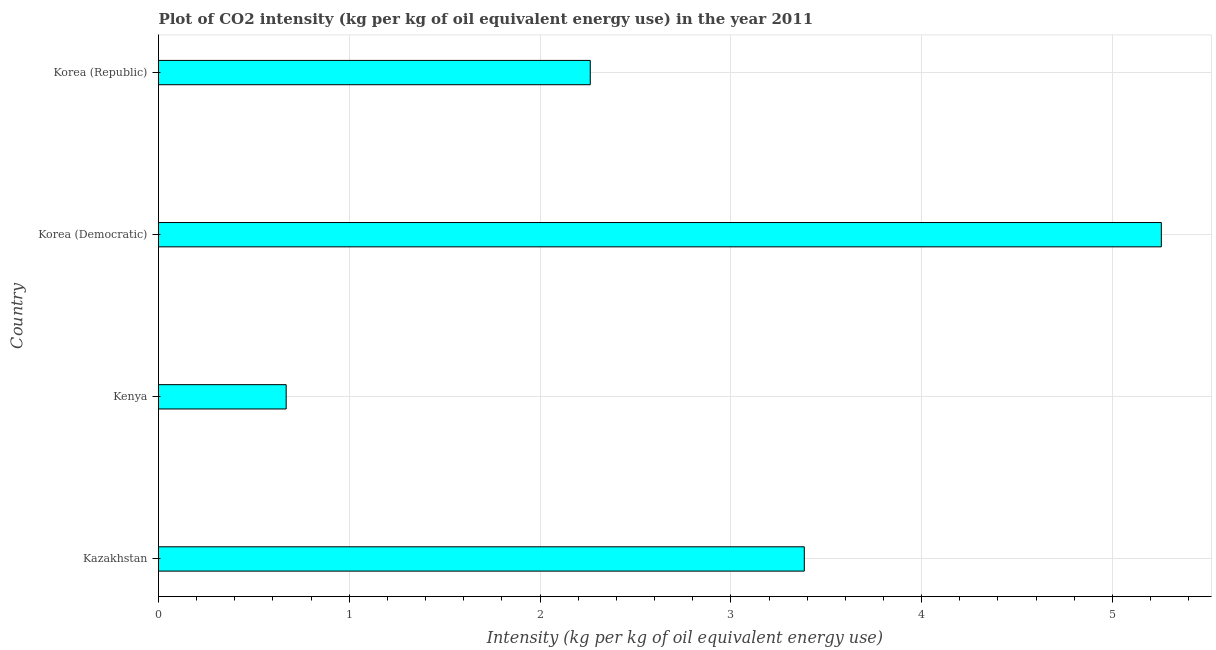What is the title of the graph?
Give a very brief answer. Plot of CO2 intensity (kg per kg of oil equivalent energy use) in the year 2011. What is the label or title of the X-axis?
Your response must be concise. Intensity (kg per kg of oil equivalent energy use). What is the label or title of the Y-axis?
Your answer should be very brief. Country. What is the co2 intensity in Korea (Democratic)?
Your answer should be very brief. 5.26. Across all countries, what is the maximum co2 intensity?
Make the answer very short. 5.26. Across all countries, what is the minimum co2 intensity?
Ensure brevity in your answer.  0.67. In which country was the co2 intensity maximum?
Your answer should be very brief. Korea (Democratic). In which country was the co2 intensity minimum?
Your answer should be very brief. Kenya. What is the sum of the co2 intensity?
Your answer should be compact. 11.57. What is the difference between the co2 intensity in Kenya and Korea (Republic)?
Offer a very short reply. -1.59. What is the average co2 intensity per country?
Ensure brevity in your answer.  2.89. What is the median co2 intensity?
Offer a very short reply. 2.82. What is the ratio of the co2 intensity in Kazakhstan to that in Korea (Democratic)?
Provide a short and direct response. 0.64. Is the co2 intensity in Kenya less than that in Korea (Democratic)?
Give a very brief answer. Yes. What is the difference between the highest and the second highest co2 intensity?
Provide a succinct answer. 1.87. What is the difference between the highest and the lowest co2 intensity?
Your response must be concise. 4.59. In how many countries, is the co2 intensity greater than the average co2 intensity taken over all countries?
Your answer should be very brief. 2. What is the difference between two consecutive major ticks on the X-axis?
Offer a very short reply. 1. Are the values on the major ticks of X-axis written in scientific E-notation?
Ensure brevity in your answer.  No. What is the Intensity (kg per kg of oil equivalent energy use) of Kazakhstan?
Keep it short and to the point. 3.38. What is the Intensity (kg per kg of oil equivalent energy use) in Kenya?
Your answer should be very brief. 0.67. What is the Intensity (kg per kg of oil equivalent energy use) of Korea (Democratic)?
Provide a short and direct response. 5.26. What is the Intensity (kg per kg of oil equivalent energy use) of Korea (Republic)?
Provide a succinct answer. 2.26. What is the difference between the Intensity (kg per kg of oil equivalent energy use) in Kazakhstan and Kenya?
Offer a very short reply. 2.72. What is the difference between the Intensity (kg per kg of oil equivalent energy use) in Kazakhstan and Korea (Democratic)?
Your response must be concise. -1.87. What is the difference between the Intensity (kg per kg of oil equivalent energy use) in Kazakhstan and Korea (Republic)?
Offer a terse response. 1.12. What is the difference between the Intensity (kg per kg of oil equivalent energy use) in Kenya and Korea (Democratic)?
Your answer should be compact. -4.59. What is the difference between the Intensity (kg per kg of oil equivalent energy use) in Kenya and Korea (Republic)?
Provide a succinct answer. -1.59. What is the difference between the Intensity (kg per kg of oil equivalent energy use) in Korea (Democratic) and Korea (Republic)?
Your answer should be compact. 2.99. What is the ratio of the Intensity (kg per kg of oil equivalent energy use) in Kazakhstan to that in Kenya?
Give a very brief answer. 5.06. What is the ratio of the Intensity (kg per kg of oil equivalent energy use) in Kazakhstan to that in Korea (Democratic)?
Give a very brief answer. 0.64. What is the ratio of the Intensity (kg per kg of oil equivalent energy use) in Kazakhstan to that in Korea (Republic)?
Your answer should be compact. 1.5. What is the ratio of the Intensity (kg per kg of oil equivalent energy use) in Kenya to that in Korea (Democratic)?
Offer a very short reply. 0.13. What is the ratio of the Intensity (kg per kg of oil equivalent energy use) in Kenya to that in Korea (Republic)?
Your answer should be compact. 0.3. What is the ratio of the Intensity (kg per kg of oil equivalent energy use) in Korea (Democratic) to that in Korea (Republic)?
Give a very brief answer. 2.32. 